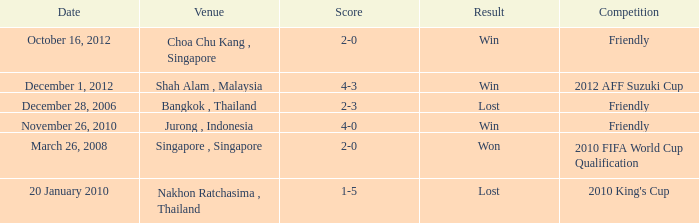Name the date for score of 1-5 20 January 2010. 